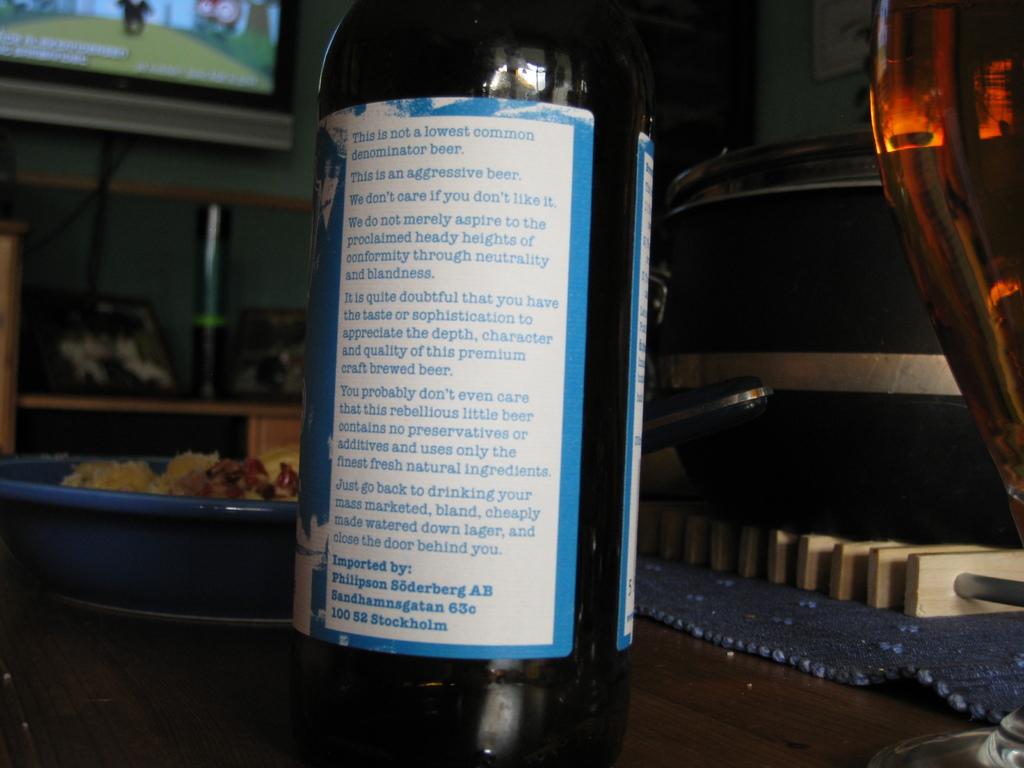What is the first sentence on the bottle?
Offer a very short reply. This is not a lowest common denominator beer. 